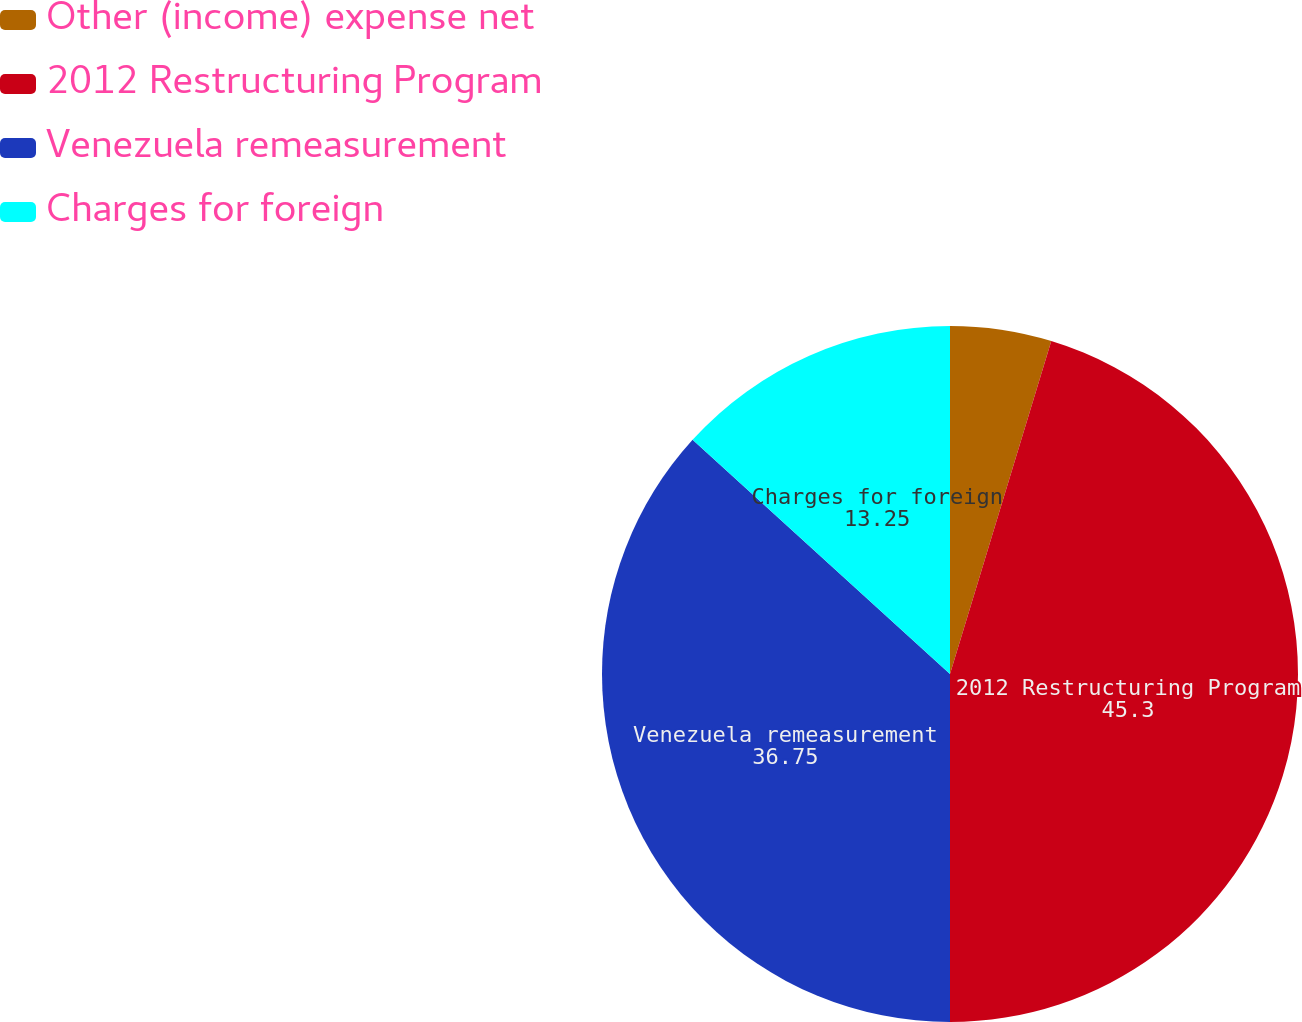Convert chart to OTSL. <chart><loc_0><loc_0><loc_500><loc_500><pie_chart><fcel>Other (income) expense net<fcel>2012 Restructuring Program<fcel>Venezuela remeasurement<fcel>Charges for foreign<nl><fcel>4.7%<fcel>45.3%<fcel>36.75%<fcel>13.25%<nl></chart> 